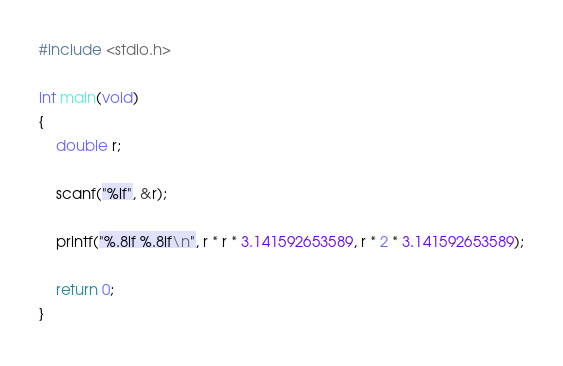Convert code to text. <code><loc_0><loc_0><loc_500><loc_500><_C_>#include <stdio.h>

int main(void)
{
    double r;

    scanf("%lf", &r);

    printf("%.8lf %.8lf\n", r * r * 3.141592653589, r * 2 * 3.141592653589);

    return 0;
}</code> 